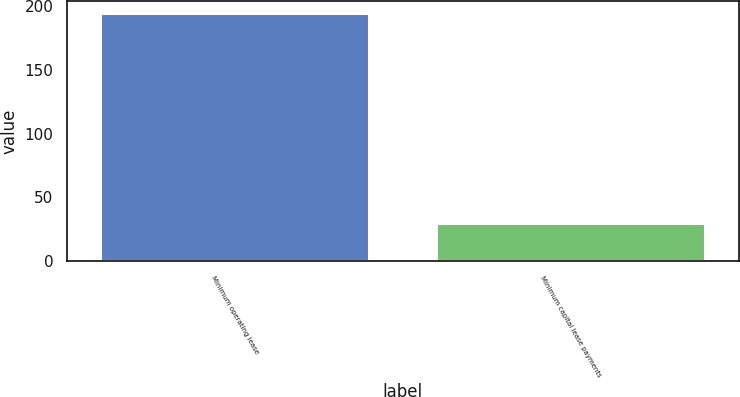Convert chart to OTSL. <chart><loc_0><loc_0><loc_500><loc_500><bar_chart><fcel>Minimum operating lease<fcel>Minimum capital lease payments<nl><fcel>194<fcel>30<nl></chart> 